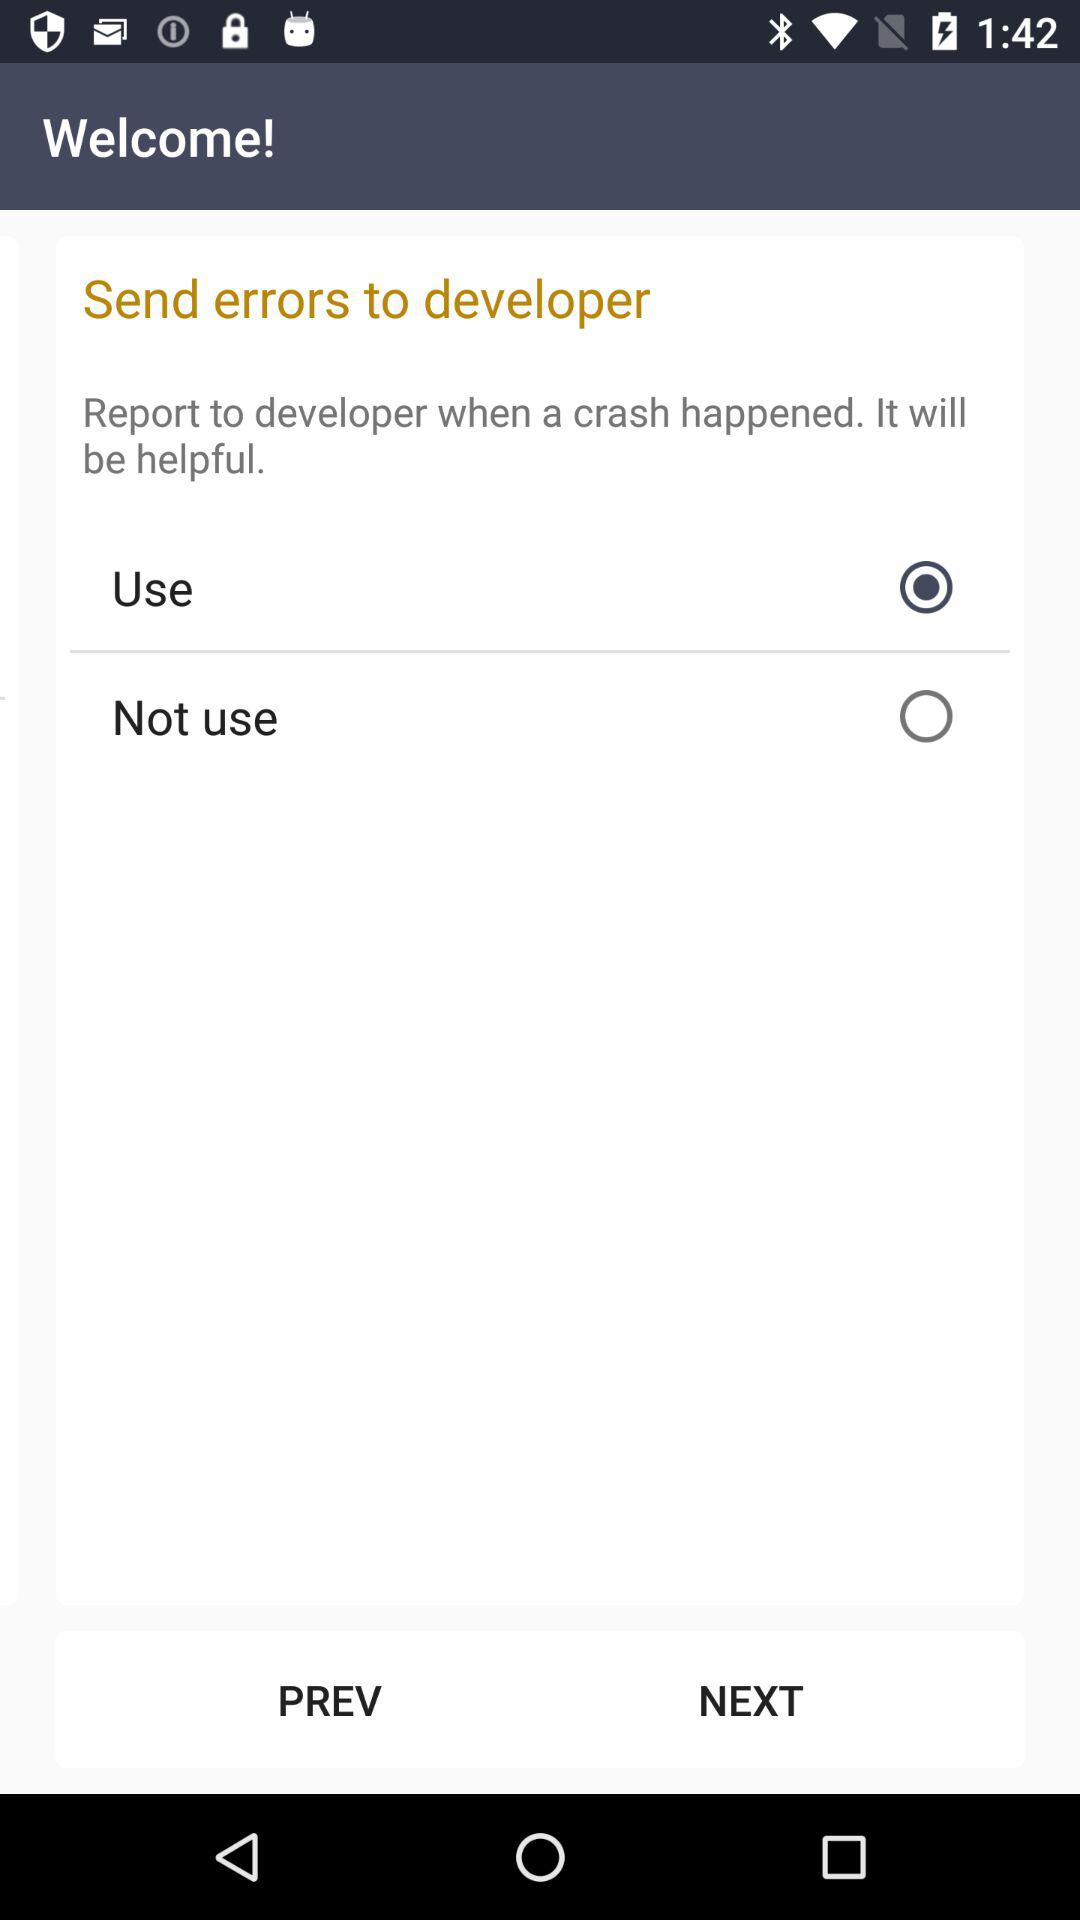Which option is selected? The selected option is "Use". 